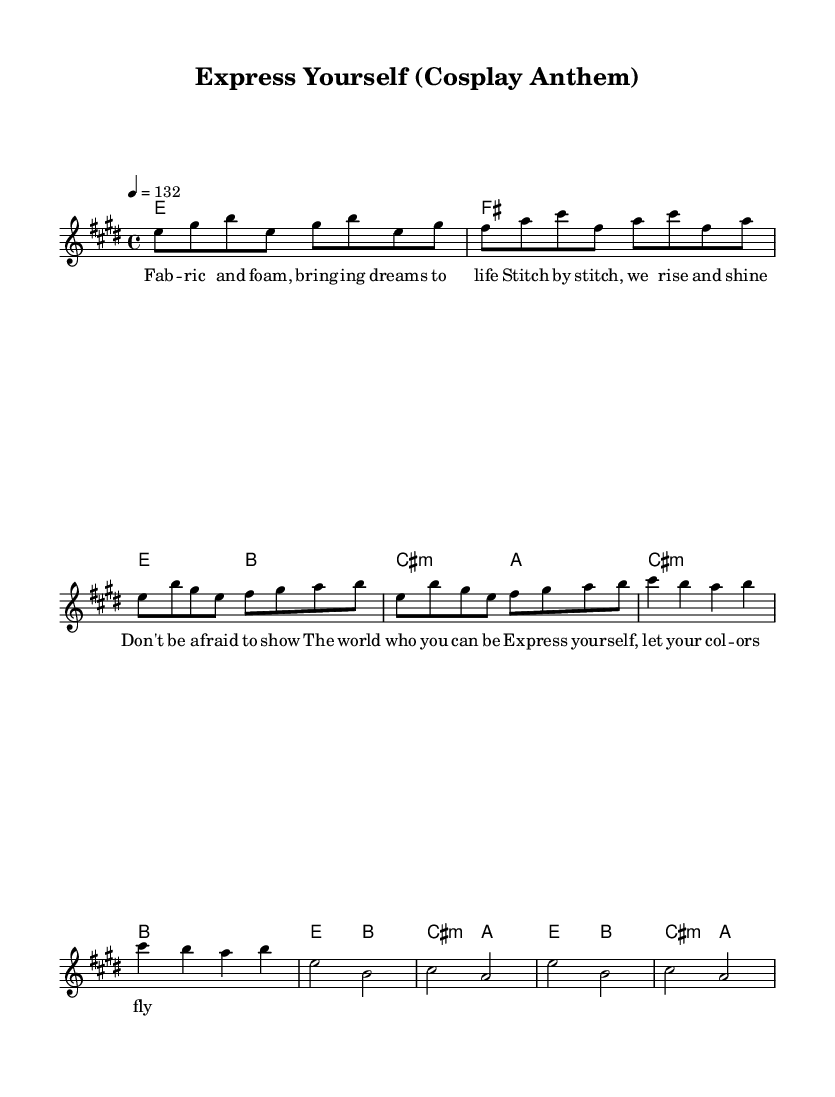What is the key signature of this music? The key signature, indicated at the beginning of the sheet music, shows that there are four sharps (F#, C#, G#, D#). These correspond to the E Major scale, thus confirming that the key signature is E Major.
Answer: E major What is the time signature of this music? The time signature is found at the beginning of the sheet music, indicated as "4/4." This means there are four beats in each measure, and the quarter note receives one beat.
Answer: 4/4 What is the tempo marking of this music? The tempo marking is also located at the beginning of the sheet music. It is indicated as "4 = 132," which means that the music should be played at a speed of 132 beats per minute.
Answer: 132 How many measures are in the verse section? To find the number of measures in the verse, we need to analyze the verse lyrics and corresponding notes. Counting the measures from the melody and harmonies during the verse, we find that there are four measures total.
Answer: 4 What is the first note of the chorus? Looking at the melody for the chorus section, the first note is "e," which appears clearly at the start of the chorus part in the score.
Answer: e How do the lyrics reflect self-expression in the song? The lyrics in the verse prominently feature themes of individuality and creativity, encouraging self-expression through phrases like "Don't be afraid to show the world who you can be." This reflects a strong message of empowerment and the celebration of one's unique identity.
Answer: Empowerment 